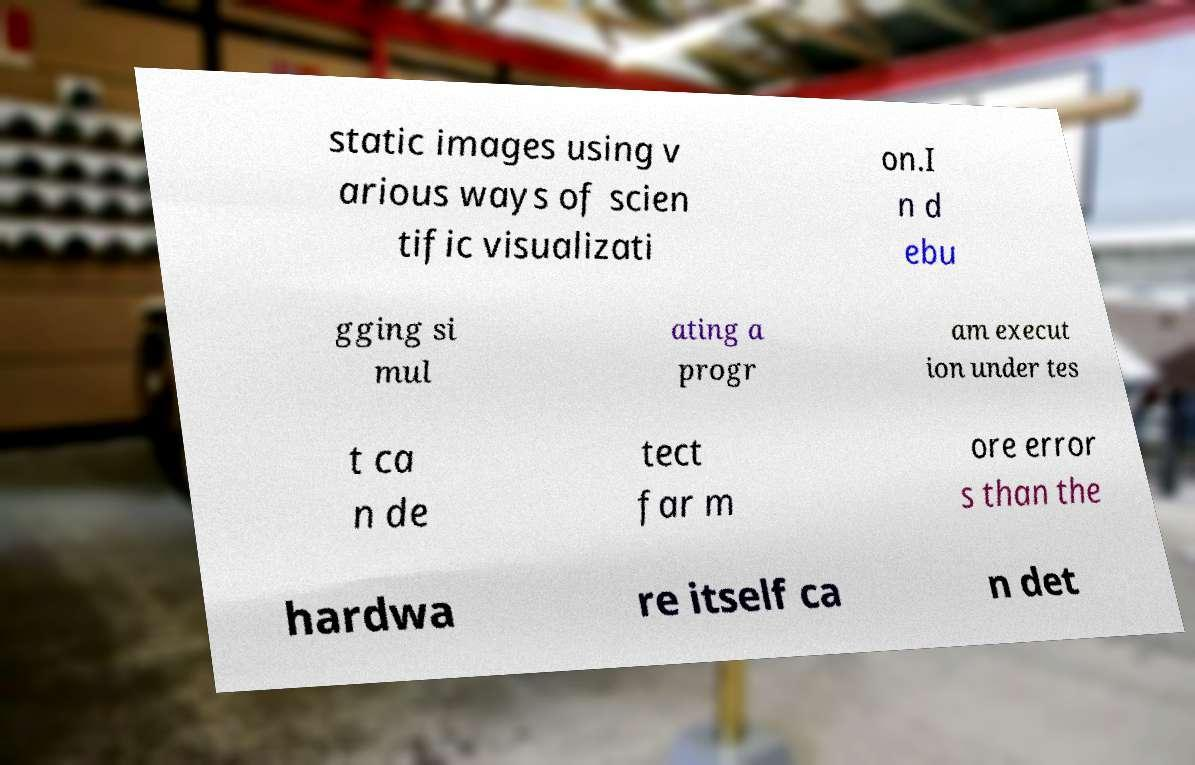For documentation purposes, I need the text within this image transcribed. Could you provide that? static images using v arious ways of scien tific visualizati on.I n d ebu gging si mul ating a progr am execut ion under tes t ca n de tect far m ore error s than the hardwa re itself ca n det 